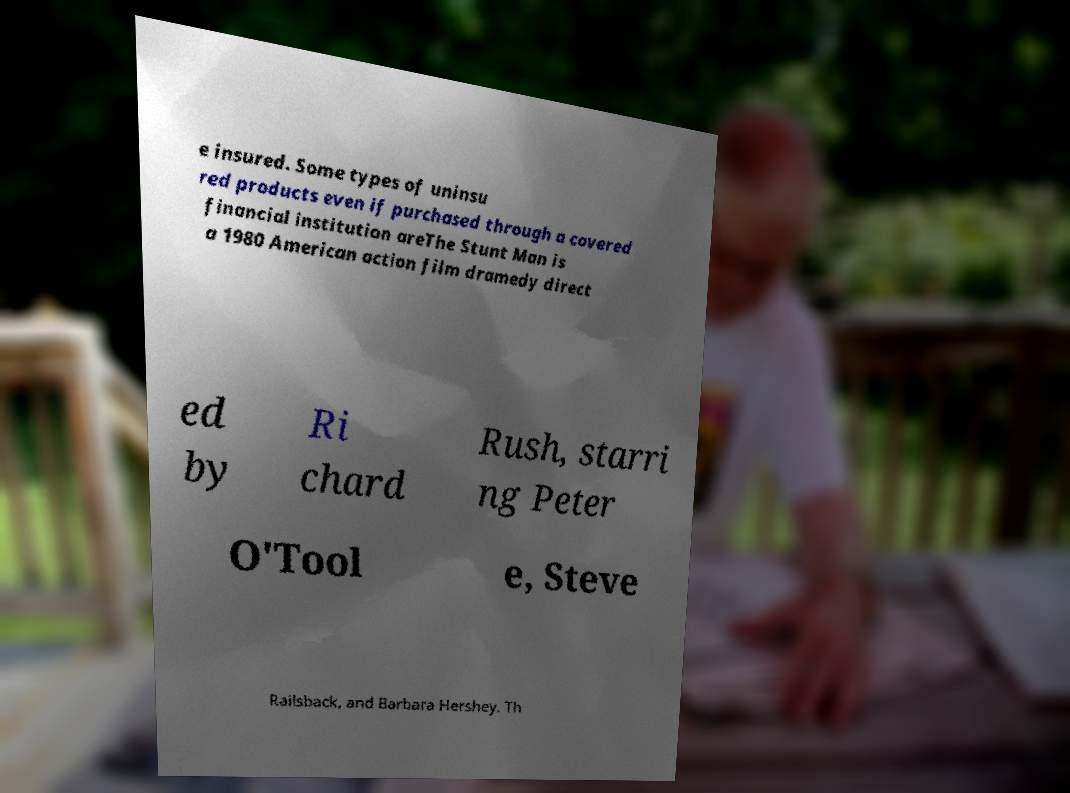There's text embedded in this image that I need extracted. Can you transcribe it verbatim? e insured. Some types of uninsu red products even if purchased through a covered financial institution areThe Stunt Man is a 1980 American action film dramedy direct ed by Ri chard Rush, starri ng Peter O'Tool e, Steve Railsback, and Barbara Hershey. Th 